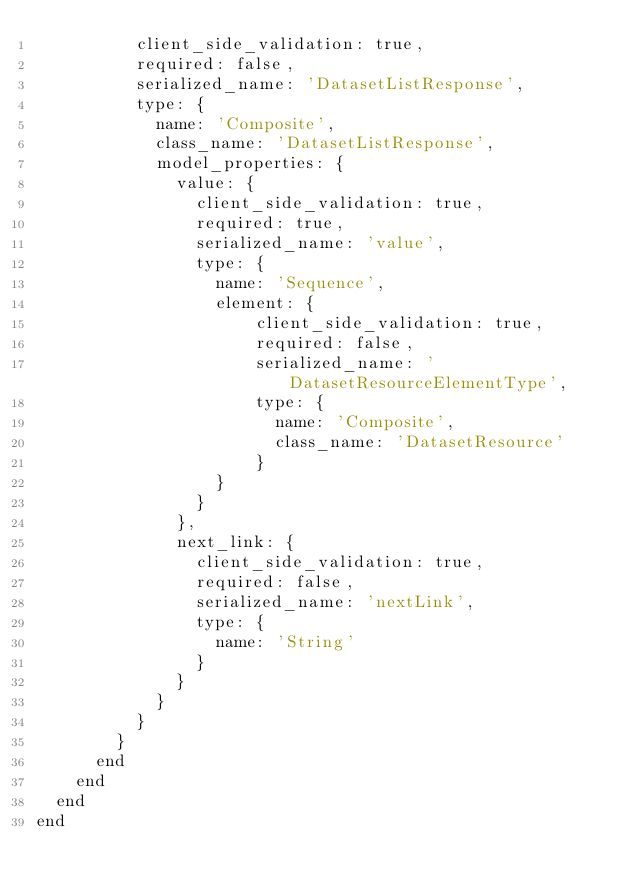Convert code to text. <code><loc_0><loc_0><loc_500><loc_500><_Ruby_>          client_side_validation: true,
          required: false,
          serialized_name: 'DatasetListResponse',
          type: {
            name: 'Composite',
            class_name: 'DatasetListResponse',
            model_properties: {
              value: {
                client_side_validation: true,
                required: true,
                serialized_name: 'value',
                type: {
                  name: 'Sequence',
                  element: {
                      client_side_validation: true,
                      required: false,
                      serialized_name: 'DatasetResourceElementType',
                      type: {
                        name: 'Composite',
                        class_name: 'DatasetResource'
                      }
                  }
                }
              },
              next_link: {
                client_side_validation: true,
                required: false,
                serialized_name: 'nextLink',
                type: {
                  name: 'String'
                }
              }
            }
          }
        }
      end
    end
  end
end
</code> 